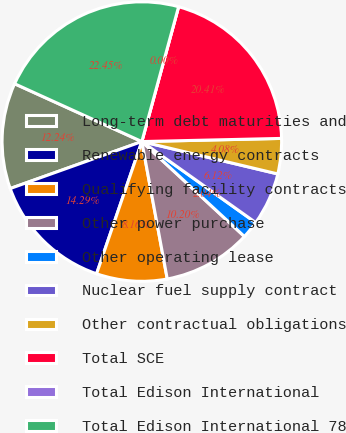Convert chart. <chart><loc_0><loc_0><loc_500><loc_500><pie_chart><fcel>Long-term debt maturities and<fcel>Renewable energy contracts<fcel>Qualifying facility contracts<fcel>Other power purchase<fcel>Other operating lease<fcel>Nuclear fuel supply contract<fcel>Other contractual obligations<fcel>Total SCE<fcel>Total Edison International<fcel>Total Edison International 78<nl><fcel>12.24%<fcel>14.29%<fcel>8.16%<fcel>10.2%<fcel>2.04%<fcel>6.12%<fcel>4.08%<fcel>20.4%<fcel>0.0%<fcel>22.44%<nl></chart> 